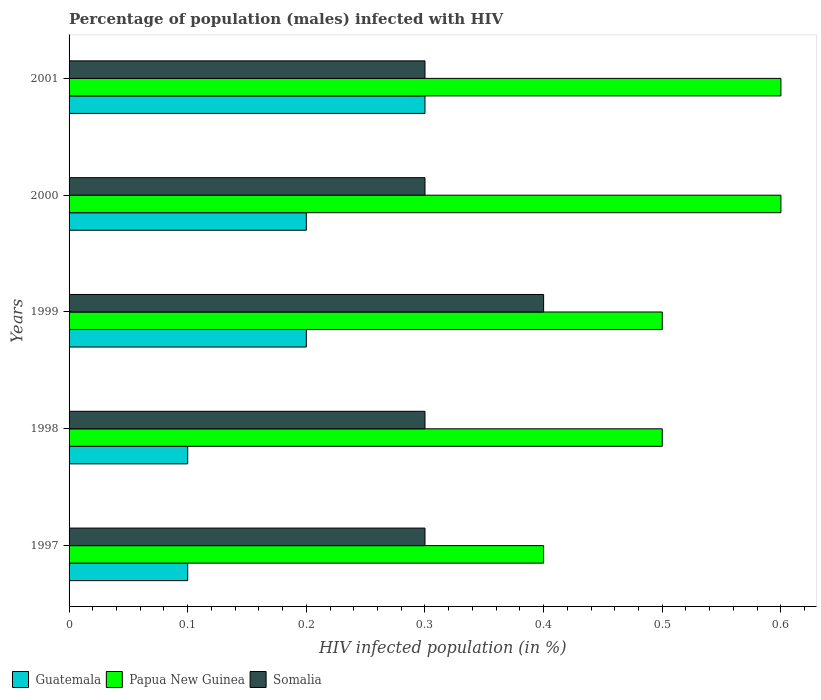How many different coloured bars are there?
Provide a short and direct response. 3. How many groups of bars are there?
Provide a succinct answer. 5. How many bars are there on the 3rd tick from the bottom?
Your response must be concise. 3. In how many cases, is the number of bars for a given year not equal to the number of legend labels?
Your answer should be very brief. 0. What is the percentage of HIV infected male population in Somalia in 1998?
Give a very brief answer. 0.3. Across all years, what is the maximum percentage of HIV infected male population in Guatemala?
Give a very brief answer. 0.3. Across all years, what is the minimum percentage of HIV infected male population in Somalia?
Make the answer very short. 0.3. In which year was the percentage of HIV infected male population in Guatemala maximum?
Provide a short and direct response. 2001. What is the total percentage of HIV infected male population in Somalia in the graph?
Your answer should be very brief. 1.6. What is the average percentage of HIV infected male population in Papua New Guinea per year?
Offer a very short reply. 0.52. In the year 1998, what is the difference between the percentage of HIV infected male population in Guatemala and percentage of HIV infected male population in Somalia?
Ensure brevity in your answer.  -0.2. In how many years, is the percentage of HIV infected male population in Guatemala greater than 0.04 %?
Provide a succinct answer. 5. Is the difference between the percentage of HIV infected male population in Guatemala in 1998 and 1999 greater than the difference between the percentage of HIV infected male population in Somalia in 1998 and 1999?
Provide a succinct answer. Yes. What is the difference between the highest and the second highest percentage of HIV infected male population in Guatemala?
Make the answer very short. 0.1. What is the difference between the highest and the lowest percentage of HIV infected male population in Papua New Guinea?
Provide a short and direct response. 0.2. What does the 1st bar from the top in 1997 represents?
Provide a succinct answer. Somalia. What does the 2nd bar from the bottom in 1997 represents?
Ensure brevity in your answer.  Papua New Guinea. Is it the case that in every year, the sum of the percentage of HIV infected male population in Papua New Guinea and percentage of HIV infected male population in Guatemala is greater than the percentage of HIV infected male population in Somalia?
Offer a terse response. Yes. What is the difference between two consecutive major ticks on the X-axis?
Your answer should be very brief. 0.1. Are the values on the major ticks of X-axis written in scientific E-notation?
Keep it short and to the point. No. Does the graph contain grids?
Ensure brevity in your answer.  No. How are the legend labels stacked?
Give a very brief answer. Horizontal. What is the title of the graph?
Provide a short and direct response. Percentage of population (males) infected with HIV. Does "San Marino" appear as one of the legend labels in the graph?
Offer a very short reply. No. What is the label or title of the X-axis?
Provide a succinct answer. HIV infected population (in %). What is the HIV infected population (in %) in Guatemala in 1998?
Provide a succinct answer. 0.1. What is the HIV infected population (in %) of Papua New Guinea in 1998?
Keep it short and to the point. 0.5. What is the HIV infected population (in %) of Somalia in 1998?
Offer a very short reply. 0.3. What is the HIV infected population (in %) of Guatemala in 1999?
Provide a short and direct response. 0.2. What is the HIV infected population (in %) of Guatemala in 2000?
Your answer should be very brief. 0.2. What is the HIV infected population (in %) of Papua New Guinea in 2000?
Provide a short and direct response. 0.6. What is the HIV infected population (in %) of Guatemala in 2001?
Provide a short and direct response. 0.3. Across all years, what is the maximum HIV infected population (in %) in Guatemala?
Give a very brief answer. 0.3. Across all years, what is the maximum HIV infected population (in %) of Papua New Guinea?
Make the answer very short. 0.6. Across all years, what is the minimum HIV infected population (in %) of Papua New Guinea?
Offer a terse response. 0.4. What is the total HIV infected population (in %) in Guatemala in the graph?
Provide a succinct answer. 0.9. What is the total HIV infected population (in %) in Papua New Guinea in the graph?
Give a very brief answer. 2.6. What is the total HIV infected population (in %) of Somalia in the graph?
Your response must be concise. 1.6. What is the difference between the HIV infected population (in %) in Guatemala in 1997 and that in 1998?
Give a very brief answer. 0. What is the difference between the HIV infected population (in %) of Somalia in 1997 and that in 1998?
Your answer should be very brief. 0. What is the difference between the HIV infected population (in %) in Guatemala in 1997 and that in 1999?
Offer a terse response. -0.1. What is the difference between the HIV infected population (in %) in Papua New Guinea in 1997 and that in 1999?
Provide a short and direct response. -0.1. What is the difference between the HIV infected population (in %) in Somalia in 1997 and that in 1999?
Provide a short and direct response. -0.1. What is the difference between the HIV infected population (in %) in Guatemala in 1997 and that in 2000?
Your answer should be very brief. -0.1. What is the difference between the HIV infected population (in %) in Somalia in 1997 and that in 2000?
Your answer should be compact. 0. What is the difference between the HIV infected population (in %) in Guatemala in 1997 and that in 2001?
Provide a short and direct response. -0.2. What is the difference between the HIV infected population (in %) of Papua New Guinea in 1997 and that in 2001?
Give a very brief answer. -0.2. What is the difference between the HIV infected population (in %) of Guatemala in 1998 and that in 2001?
Your answer should be very brief. -0.2. What is the difference between the HIV infected population (in %) of Somalia in 1998 and that in 2001?
Ensure brevity in your answer.  0. What is the difference between the HIV infected population (in %) in Guatemala in 1999 and that in 2000?
Keep it short and to the point. 0. What is the difference between the HIV infected population (in %) of Somalia in 1999 and that in 2000?
Offer a very short reply. 0.1. What is the difference between the HIV infected population (in %) in Guatemala in 1999 and that in 2001?
Offer a very short reply. -0.1. What is the difference between the HIV infected population (in %) in Somalia in 1999 and that in 2001?
Make the answer very short. 0.1. What is the difference between the HIV infected population (in %) of Papua New Guinea in 2000 and that in 2001?
Make the answer very short. 0. What is the difference between the HIV infected population (in %) of Guatemala in 1997 and the HIV infected population (in %) of Papua New Guinea in 1998?
Keep it short and to the point. -0.4. What is the difference between the HIV infected population (in %) in Guatemala in 1997 and the HIV infected population (in %) in Somalia in 1998?
Offer a very short reply. -0.2. What is the difference between the HIV infected population (in %) in Guatemala in 1997 and the HIV infected population (in %) in Papua New Guinea in 1999?
Your response must be concise. -0.4. What is the difference between the HIV infected population (in %) in Papua New Guinea in 1997 and the HIV infected population (in %) in Somalia in 1999?
Provide a short and direct response. 0. What is the difference between the HIV infected population (in %) of Guatemala in 1997 and the HIV infected population (in %) of Papua New Guinea in 2000?
Offer a very short reply. -0.5. What is the difference between the HIV infected population (in %) of Guatemala in 1997 and the HIV infected population (in %) of Somalia in 2000?
Provide a succinct answer. -0.2. What is the difference between the HIV infected population (in %) of Papua New Guinea in 1997 and the HIV infected population (in %) of Somalia in 2000?
Give a very brief answer. 0.1. What is the difference between the HIV infected population (in %) of Guatemala in 1997 and the HIV infected population (in %) of Papua New Guinea in 2001?
Your response must be concise. -0.5. What is the difference between the HIV infected population (in %) in Papua New Guinea in 1997 and the HIV infected population (in %) in Somalia in 2001?
Offer a terse response. 0.1. What is the difference between the HIV infected population (in %) in Guatemala in 1998 and the HIV infected population (in %) in Papua New Guinea in 1999?
Provide a succinct answer. -0.4. What is the difference between the HIV infected population (in %) in Papua New Guinea in 1998 and the HIV infected population (in %) in Somalia in 1999?
Keep it short and to the point. 0.1. What is the difference between the HIV infected population (in %) of Papua New Guinea in 1998 and the HIV infected population (in %) of Somalia in 2000?
Your answer should be compact. 0.2. What is the difference between the HIV infected population (in %) of Guatemala in 1998 and the HIV infected population (in %) of Papua New Guinea in 2001?
Ensure brevity in your answer.  -0.5. What is the difference between the HIV infected population (in %) in Guatemala in 1998 and the HIV infected population (in %) in Somalia in 2001?
Make the answer very short. -0.2. What is the difference between the HIV infected population (in %) of Papua New Guinea in 1998 and the HIV infected population (in %) of Somalia in 2001?
Your answer should be very brief. 0.2. What is the difference between the HIV infected population (in %) of Guatemala in 1999 and the HIV infected population (in %) of Papua New Guinea in 2000?
Offer a very short reply. -0.4. What is the difference between the HIV infected population (in %) in Guatemala in 1999 and the HIV infected population (in %) in Somalia in 2000?
Ensure brevity in your answer.  -0.1. What is the difference between the HIV infected population (in %) of Papua New Guinea in 1999 and the HIV infected population (in %) of Somalia in 2000?
Offer a very short reply. 0.2. What is the difference between the HIV infected population (in %) of Papua New Guinea in 1999 and the HIV infected population (in %) of Somalia in 2001?
Provide a short and direct response. 0.2. What is the difference between the HIV infected population (in %) of Guatemala in 2000 and the HIV infected population (in %) of Somalia in 2001?
Provide a short and direct response. -0.1. What is the average HIV infected population (in %) in Guatemala per year?
Your answer should be very brief. 0.18. What is the average HIV infected population (in %) of Papua New Guinea per year?
Your answer should be compact. 0.52. What is the average HIV infected population (in %) of Somalia per year?
Your answer should be very brief. 0.32. In the year 1997, what is the difference between the HIV infected population (in %) of Papua New Guinea and HIV infected population (in %) of Somalia?
Offer a very short reply. 0.1. In the year 1998, what is the difference between the HIV infected population (in %) in Guatemala and HIV infected population (in %) in Papua New Guinea?
Ensure brevity in your answer.  -0.4. In the year 1998, what is the difference between the HIV infected population (in %) of Guatemala and HIV infected population (in %) of Somalia?
Give a very brief answer. -0.2. In the year 1999, what is the difference between the HIV infected population (in %) of Guatemala and HIV infected population (in %) of Papua New Guinea?
Provide a succinct answer. -0.3. In the year 1999, what is the difference between the HIV infected population (in %) in Guatemala and HIV infected population (in %) in Somalia?
Give a very brief answer. -0.2. In the year 1999, what is the difference between the HIV infected population (in %) of Papua New Guinea and HIV infected population (in %) of Somalia?
Your answer should be very brief. 0.1. In the year 2000, what is the difference between the HIV infected population (in %) in Guatemala and HIV infected population (in %) in Papua New Guinea?
Your answer should be compact. -0.4. In the year 2001, what is the difference between the HIV infected population (in %) in Guatemala and HIV infected population (in %) in Papua New Guinea?
Provide a short and direct response. -0.3. In the year 2001, what is the difference between the HIV infected population (in %) in Papua New Guinea and HIV infected population (in %) in Somalia?
Provide a short and direct response. 0.3. What is the ratio of the HIV infected population (in %) in Guatemala in 1997 to that in 1998?
Offer a terse response. 1. What is the ratio of the HIV infected population (in %) of Papua New Guinea in 1997 to that in 1998?
Provide a short and direct response. 0.8. What is the ratio of the HIV infected population (in %) of Somalia in 1997 to that in 1999?
Offer a terse response. 0.75. What is the ratio of the HIV infected population (in %) of Guatemala in 1997 to that in 2000?
Keep it short and to the point. 0.5. What is the ratio of the HIV infected population (in %) in Somalia in 1997 to that in 2000?
Make the answer very short. 1. What is the ratio of the HIV infected population (in %) in Papua New Guinea in 1997 to that in 2001?
Provide a short and direct response. 0.67. What is the ratio of the HIV infected population (in %) of Papua New Guinea in 1998 to that in 2000?
Offer a terse response. 0.83. What is the ratio of the HIV infected population (in %) of Somalia in 1998 to that in 2000?
Your answer should be compact. 1. What is the ratio of the HIV infected population (in %) of Papua New Guinea in 1998 to that in 2001?
Offer a very short reply. 0.83. What is the ratio of the HIV infected population (in %) of Somalia in 1998 to that in 2001?
Your response must be concise. 1. What is the ratio of the HIV infected population (in %) of Papua New Guinea in 1999 to that in 2000?
Your answer should be compact. 0.83. What is the ratio of the HIV infected population (in %) in Guatemala in 1999 to that in 2001?
Make the answer very short. 0.67. What is the ratio of the HIV infected population (in %) in Somalia in 1999 to that in 2001?
Keep it short and to the point. 1.33. What is the difference between the highest and the lowest HIV infected population (in %) in Papua New Guinea?
Your answer should be very brief. 0.2. 